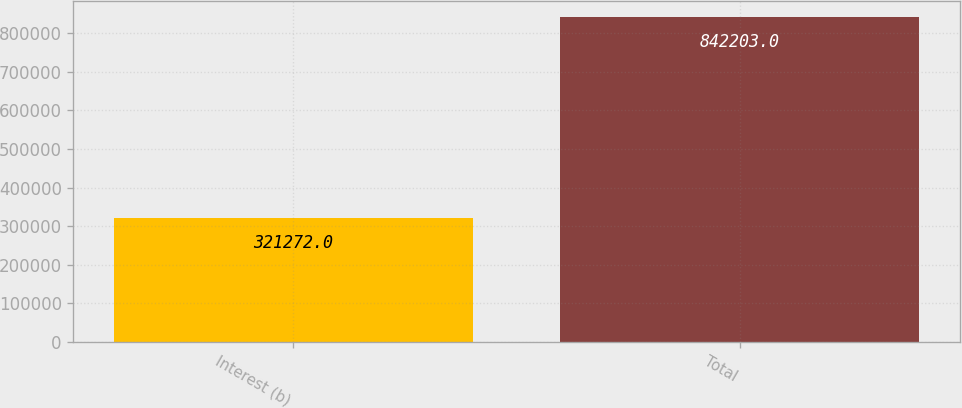<chart> <loc_0><loc_0><loc_500><loc_500><bar_chart><fcel>Interest (b)<fcel>Total<nl><fcel>321272<fcel>842203<nl></chart> 